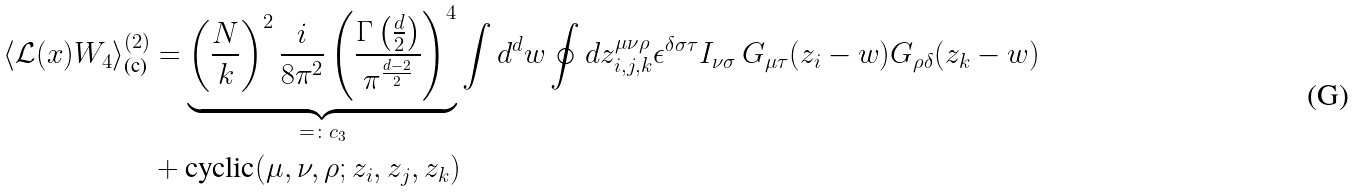Convert formula to latex. <formula><loc_0><loc_0><loc_500><loc_500>\langle \mathcal { L } ( x ) W _ { 4 } \rangle ^ { ( 2 ) } _ { \text {(c)} } & = \underbrace { \left ( \frac { N } { k } \right ) ^ { 2 } \frac { i } { 8 \pi ^ { 2 } } \left ( \frac { \Gamma \left ( \frac { d } { 2 } \right ) } { \pi ^ { \frac { d - 2 } { 2 } } } \right ) ^ { 4 } } _ { = \colon c _ { 3 } } \int d ^ { d } w \oint d z _ { i , j , k } ^ { \mu \nu \rho } \epsilon ^ { \delta \sigma \tau } I _ { \nu \sigma } \, G _ { \mu \tau } ( z _ { i } - w ) G _ { \rho \delta } ( z _ { k } - w ) \\ & + \text {cyclic} ( \mu , \nu , \rho ; z _ { i } , z _ { j } , z _ { k } )</formula> 